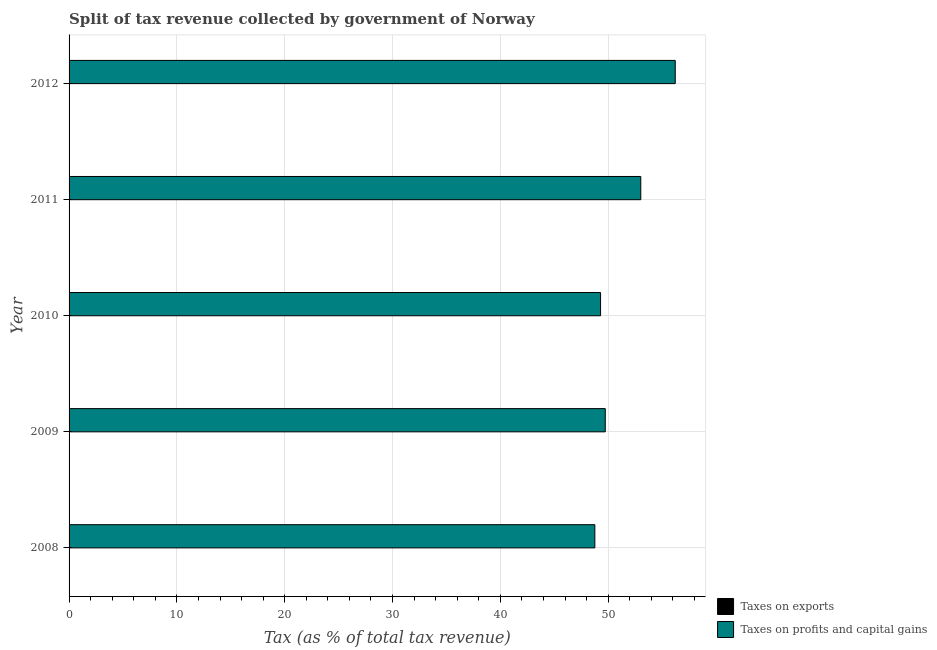How many groups of bars are there?
Offer a very short reply. 5. How many bars are there on the 3rd tick from the top?
Keep it short and to the point. 2. How many bars are there on the 5th tick from the bottom?
Your answer should be very brief. 2. What is the percentage of revenue obtained from taxes on profits and capital gains in 2010?
Your answer should be very brief. 49.3. Across all years, what is the maximum percentage of revenue obtained from taxes on exports?
Your answer should be very brief. 0.02. Across all years, what is the minimum percentage of revenue obtained from taxes on profits and capital gains?
Keep it short and to the point. 48.76. In which year was the percentage of revenue obtained from taxes on exports maximum?
Keep it short and to the point. 2011. In which year was the percentage of revenue obtained from taxes on exports minimum?
Your answer should be very brief. 2008. What is the total percentage of revenue obtained from taxes on profits and capital gains in the graph?
Provide a short and direct response. 257.04. What is the difference between the percentage of revenue obtained from taxes on profits and capital gains in 2009 and that in 2010?
Keep it short and to the point. 0.43. What is the difference between the percentage of revenue obtained from taxes on exports in 2012 and the percentage of revenue obtained from taxes on profits and capital gains in 2011?
Your answer should be very brief. -53. What is the average percentage of revenue obtained from taxes on exports per year?
Your answer should be compact. 0.02. In the year 2008, what is the difference between the percentage of revenue obtained from taxes on exports and percentage of revenue obtained from taxes on profits and capital gains?
Your answer should be compact. -48.75. In how many years, is the percentage of revenue obtained from taxes on exports greater than 8 %?
Offer a very short reply. 0. What is the ratio of the percentage of revenue obtained from taxes on profits and capital gains in 2009 to that in 2010?
Your response must be concise. 1.01. What is the difference between the highest and the second highest percentage of revenue obtained from taxes on profits and capital gains?
Your answer should be compact. 3.2. What is the difference between the highest and the lowest percentage of revenue obtained from taxes on profits and capital gains?
Your answer should be compact. 7.46. Is the sum of the percentage of revenue obtained from taxes on profits and capital gains in 2011 and 2012 greater than the maximum percentage of revenue obtained from taxes on exports across all years?
Offer a terse response. Yes. What does the 2nd bar from the top in 2011 represents?
Your answer should be very brief. Taxes on exports. What does the 1st bar from the bottom in 2012 represents?
Offer a terse response. Taxes on exports. Are all the bars in the graph horizontal?
Provide a short and direct response. Yes. How many years are there in the graph?
Make the answer very short. 5. Are the values on the major ticks of X-axis written in scientific E-notation?
Ensure brevity in your answer.  No. Does the graph contain grids?
Your answer should be compact. Yes. How are the legend labels stacked?
Give a very brief answer. Vertical. What is the title of the graph?
Offer a very short reply. Split of tax revenue collected by government of Norway. Does "Age 65(female)" appear as one of the legend labels in the graph?
Offer a terse response. No. What is the label or title of the X-axis?
Make the answer very short. Tax (as % of total tax revenue). What is the Tax (as % of total tax revenue) in Taxes on exports in 2008?
Keep it short and to the point. 0.02. What is the Tax (as % of total tax revenue) in Taxes on profits and capital gains in 2008?
Offer a very short reply. 48.76. What is the Tax (as % of total tax revenue) of Taxes on exports in 2009?
Make the answer very short. 0.02. What is the Tax (as % of total tax revenue) of Taxes on profits and capital gains in 2009?
Your answer should be compact. 49.73. What is the Tax (as % of total tax revenue) of Taxes on exports in 2010?
Offer a terse response. 0.02. What is the Tax (as % of total tax revenue) in Taxes on profits and capital gains in 2010?
Your response must be concise. 49.3. What is the Tax (as % of total tax revenue) of Taxes on exports in 2011?
Your answer should be compact. 0.02. What is the Tax (as % of total tax revenue) in Taxes on profits and capital gains in 2011?
Provide a short and direct response. 53.03. What is the Tax (as % of total tax revenue) in Taxes on exports in 2012?
Your response must be concise. 0.02. What is the Tax (as % of total tax revenue) of Taxes on profits and capital gains in 2012?
Your answer should be very brief. 56.22. Across all years, what is the maximum Tax (as % of total tax revenue) in Taxes on exports?
Your answer should be compact. 0.02. Across all years, what is the maximum Tax (as % of total tax revenue) of Taxes on profits and capital gains?
Offer a terse response. 56.22. Across all years, what is the minimum Tax (as % of total tax revenue) of Taxes on exports?
Ensure brevity in your answer.  0.02. Across all years, what is the minimum Tax (as % of total tax revenue) of Taxes on profits and capital gains?
Make the answer very short. 48.76. What is the total Tax (as % of total tax revenue) of Taxes on exports in the graph?
Provide a succinct answer. 0.1. What is the total Tax (as % of total tax revenue) of Taxes on profits and capital gains in the graph?
Offer a very short reply. 257.04. What is the difference between the Tax (as % of total tax revenue) of Taxes on exports in 2008 and that in 2009?
Offer a very short reply. -0. What is the difference between the Tax (as % of total tax revenue) in Taxes on profits and capital gains in 2008 and that in 2009?
Give a very brief answer. -0.97. What is the difference between the Tax (as % of total tax revenue) in Taxes on exports in 2008 and that in 2010?
Make the answer very short. -0.01. What is the difference between the Tax (as % of total tax revenue) in Taxes on profits and capital gains in 2008 and that in 2010?
Provide a succinct answer. -0.53. What is the difference between the Tax (as % of total tax revenue) of Taxes on exports in 2008 and that in 2011?
Your answer should be very brief. -0.01. What is the difference between the Tax (as % of total tax revenue) of Taxes on profits and capital gains in 2008 and that in 2011?
Offer a terse response. -4.26. What is the difference between the Tax (as % of total tax revenue) in Taxes on exports in 2008 and that in 2012?
Your answer should be very brief. -0. What is the difference between the Tax (as % of total tax revenue) in Taxes on profits and capital gains in 2008 and that in 2012?
Your response must be concise. -7.46. What is the difference between the Tax (as % of total tax revenue) in Taxes on exports in 2009 and that in 2010?
Offer a very short reply. -0. What is the difference between the Tax (as % of total tax revenue) of Taxes on profits and capital gains in 2009 and that in 2010?
Provide a short and direct response. 0.44. What is the difference between the Tax (as % of total tax revenue) in Taxes on exports in 2009 and that in 2011?
Offer a very short reply. -0. What is the difference between the Tax (as % of total tax revenue) of Taxes on profits and capital gains in 2009 and that in 2011?
Provide a succinct answer. -3.3. What is the difference between the Tax (as % of total tax revenue) of Taxes on exports in 2009 and that in 2012?
Your answer should be very brief. -0. What is the difference between the Tax (as % of total tax revenue) in Taxes on profits and capital gains in 2009 and that in 2012?
Offer a very short reply. -6.49. What is the difference between the Tax (as % of total tax revenue) of Taxes on exports in 2010 and that in 2011?
Keep it short and to the point. -0. What is the difference between the Tax (as % of total tax revenue) of Taxes on profits and capital gains in 2010 and that in 2011?
Your answer should be compact. -3.73. What is the difference between the Tax (as % of total tax revenue) of Taxes on exports in 2010 and that in 2012?
Ensure brevity in your answer.  0. What is the difference between the Tax (as % of total tax revenue) of Taxes on profits and capital gains in 2010 and that in 2012?
Provide a succinct answer. -6.93. What is the difference between the Tax (as % of total tax revenue) in Taxes on exports in 2011 and that in 2012?
Keep it short and to the point. 0. What is the difference between the Tax (as % of total tax revenue) of Taxes on profits and capital gains in 2011 and that in 2012?
Make the answer very short. -3.2. What is the difference between the Tax (as % of total tax revenue) of Taxes on exports in 2008 and the Tax (as % of total tax revenue) of Taxes on profits and capital gains in 2009?
Your answer should be very brief. -49.71. What is the difference between the Tax (as % of total tax revenue) in Taxes on exports in 2008 and the Tax (as % of total tax revenue) in Taxes on profits and capital gains in 2010?
Make the answer very short. -49.28. What is the difference between the Tax (as % of total tax revenue) in Taxes on exports in 2008 and the Tax (as % of total tax revenue) in Taxes on profits and capital gains in 2011?
Provide a short and direct response. -53.01. What is the difference between the Tax (as % of total tax revenue) in Taxes on exports in 2008 and the Tax (as % of total tax revenue) in Taxes on profits and capital gains in 2012?
Make the answer very short. -56.21. What is the difference between the Tax (as % of total tax revenue) in Taxes on exports in 2009 and the Tax (as % of total tax revenue) in Taxes on profits and capital gains in 2010?
Keep it short and to the point. -49.27. What is the difference between the Tax (as % of total tax revenue) in Taxes on exports in 2009 and the Tax (as % of total tax revenue) in Taxes on profits and capital gains in 2011?
Ensure brevity in your answer.  -53.01. What is the difference between the Tax (as % of total tax revenue) of Taxes on exports in 2009 and the Tax (as % of total tax revenue) of Taxes on profits and capital gains in 2012?
Your answer should be very brief. -56.2. What is the difference between the Tax (as % of total tax revenue) in Taxes on exports in 2010 and the Tax (as % of total tax revenue) in Taxes on profits and capital gains in 2011?
Offer a terse response. -53. What is the difference between the Tax (as % of total tax revenue) in Taxes on exports in 2010 and the Tax (as % of total tax revenue) in Taxes on profits and capital gains in 2012?
Keep it short and to the point. -56.2. What is the difference between the Tax (as % of total tax revenue) of Taxes on exports in 2011 and the Tax (as % of total tax revenue) of Taxes on profits and capital gains in 2012?
Keep it short and to the point. -56.2. What is the average Tax (as % of total tax revenue) of Taxes on exports per year?
Provide a short and direct response. 0.02. What is the average Tax (as % of total tax revenue) in Taxes on profits and capital gains per year?
Offer a terse response. 51.41. In the year 2008, what is the difference between the Tax (as % of total tax revenue) of Taxes on exports and Tax (as % of total tax revenue) of Taxes on profits and capital gains?
Ensure brevity in your answer.  -48.75. In the year 2009, what is the difference between the Tax (as % of total tax revenue) in Taxes on exports and Tax (as % of total tax revenue) in Taxes on profits and capital gains?
Provide a short and direct response. -49.71. In the year 2010, what is the difference between the Tax (as % of total tax revenue) of Taxes on exports and Tax (as % of total tax revenue) of Taxes on profits and capital gains?
Provide a short and direct response. -49.27. In the year 2011, what is the difference between the Tax (as % of total tax revenue) in Taxes on exports and Tax (as % of total tax revenue) in Taxes on profits and capital gains?
Your response must be concise. -53. In the year 2012, what is the difference between the Tax (as % of total tax revenue) in Taxes on exports and Tax (as % of total tax revenue) in Taxes on profits and capital gains?
Offer a very short reply. -56.2. What is the ratio of the Tax (as % of total tax revenue) in Taxes on exports in 2008 to that in 2009?
Ensure brevity in your answer.  0.8. What is the ratio of the Tax (as % of total tax revenue) in Taxes on profits and capital gains in 2008 to that in 2009?
Make the answer very short. 0.98. What is the ratio of the Tax (as % of total tax revenue) of Taxes on exports in 2008 to that in 2010?
Provide a short and direct response. 0.77. What is the ratio of the Tax (as % of total tax revenue) of Taxes on exports in 2008 to that in 2011?
Offer a terse response. 0.75. What is the ratio of the Tax (as % of total tax revenue) of Taxes on profits and capital gains in 2008 to that in 2011?
Offer a terse response. 0.92. What is the ratio of the Tax (as % of total tax revenue) in Taxes on exports in 2008 to that in 2012?
Make the answer very short. 0.77. What is the ratio of the Tax (as % of total tax revenue) in Taxes on profits and capital gains in 2008 to that in 2012?
Your answer should be very brief. 0.87. What is the ratio of the Tax (as % of total tax revenue) in Taxes on exports in 2009 to that in 2010?
Offer a terse response. 0.96. What is the ratio of the Tax (as % of total tax revenue) of Taxes on profits and capital gains in 2009 to that in 2010?
Your answer should be very brief. 1.01. What is the ratio of the Tax (as % of total tax revenue) of Taxes on exports in 2009 to that in 2011?
Your response must be concise. 0.93. What is the ratio of the Tax (as % of total tax revenue) of Taxes on profits and capital gains in 2009 to that in 2011?
Provide a succinct answer. 0.94. What is the ratio of the Tax (as % of total tax revenue) in Taxes on exports in 2009 to that in 2012?
Make the answer very short. 0.97. What is the ratio of the Tax (as % of total tax revenue) in Taxes on profits and capital gains in 2009 to that in 2012?
Your response must be concise. 0.88. What is the ratio of the Tax (as % of total tax revenue) of Taxes on exports in 2010 to that in 2011?
Keep it short and to the point. 0.97. What is the ratio of the Tax (as % of total tax revenue) in Taxes on profits and capital gains in 2010 to that in 2011?
Give a very brief answer. 0.93. What is the ratio of the Tax (as % of total tax revenue) in Taxes on exports in 2010 to that in 2012?
Give a very brief answer. 1.01. What is the ratio of the Tax (as % of total tax revenue) in Taxes on profits and capital gains in 2010 to that in 2012?
Offer a terse response. 0.88. What is the ratio of the Tax (as % of total tax revenue) in Taxes on exports in 2011 to that in 2012?
Provide a short and direct response. 1.04. What is the ratio of the Tax (as % of total tax revenue) in Taxes on profits and capital gains in 2011 to that in 2012?
Make the answer very short. 0.94. What is the difference between the highest and the second highest Tax (as % of total tax revenue) in Taxes on exports?
Offer a very short reply. 0. What is the difference between the highest and the second highest Tax (as % of total tax revenue) of Taxes on profits and capital gains?
Make the answer very short. 3.2. What is the difference between the highest and the lowest Tax (as % of total tax revenue) of Taxes on exports?
Your answer should be compact. 0.01. What is the difference between the highest and the lowest Tax (as % of total tax revenue) in Taxes on profits and capital gains?
Offer a terse response. 7.46. 